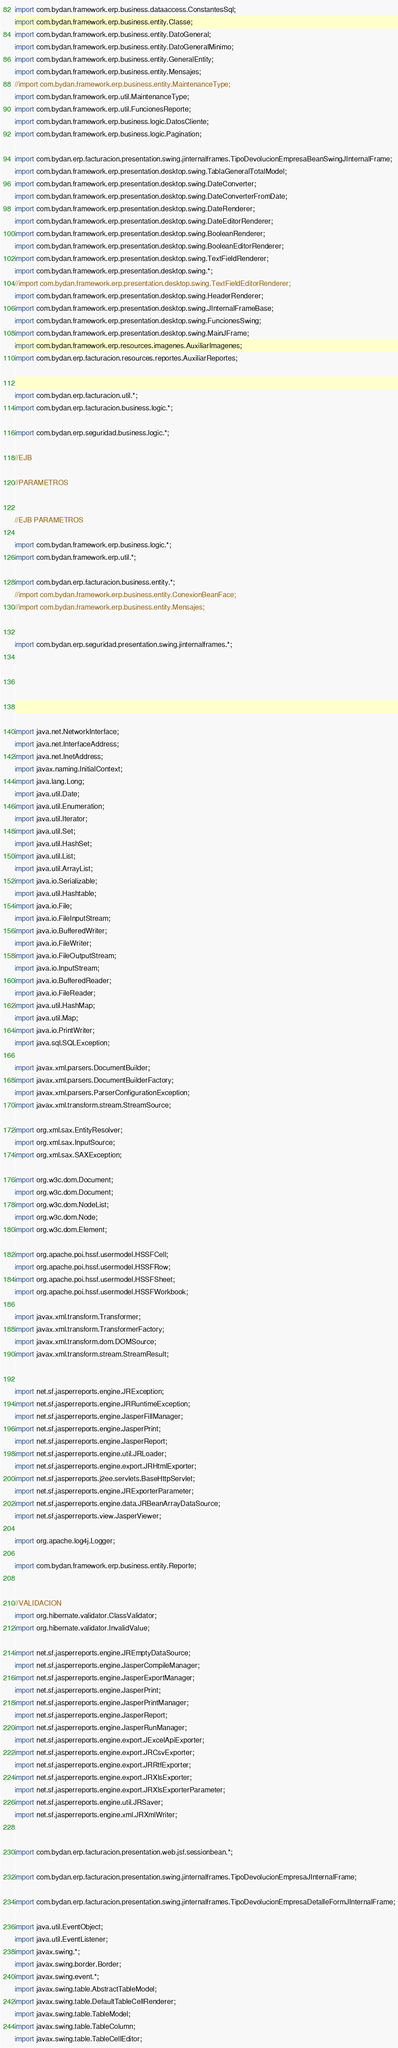Convert code to text. <code><loc_0><loc_0><loc_500><loc_500><_Java_>import com.bydan.framework.erp.business.dataaccess.ConstantesSql;
import com.bydan.framework.erp.business.entity.Classe;
import com.bydan.framework.erp.business.entity.DatoGeneral;
import com.bydan.framework.erp.business.entity.DatoGeneralMinimo;
import com.bydan.framework.erp.business.entity.GeneralEntity;
import com.bydan.framework.erp.business.entity.Mensajes;
//import com.bydan.framework.erp.business.entity.MaintenanceType;
import com.bydan.framework.erp.util.MaintenanceType;
import com.bydan.framework.erp.util.FuncionesReporte;
import com.bydan.framework.erp.business.logic.DatosCliente;
import com.bydan.framework.erp.business.logic.Pagination;

import com.bydan.erp.facturacion.presentation.swing.jinternalframes.TipoDevolucionEmpresaBeanSwingJInternalFrame;
import com.bydan.framework.erp.presentation.desktop.swing.TablaGeneralTotalModel;
import com.bydan.framework.erp.presentation.desktop.swing.DateConverter;
import com.bydan.framework.erp.presentation.desktop.swing.DateConverterFromDate;
import com.bydan.framework.erp.presentation.desktop.swing.DateRenderer;
import com.bydan.framework.erp.presentation.desktop.swing.DateEditorRenderer;
import com.bydan.framework.erp.presentation.desktop.swing.BooleanRenderer;
import com.bydan.framework.erp.presentation.desktop.swing.BooleanEditorRenderer;
import com.bydan.framework.erp.presentation.desktop.swing.TextFieldRenderer;
import com.bydan.framework.erp.presentation.desktop.swing.*;
//import com.bydan.framework.erp.presentation.desktop.swing.TextFieldEditorRenderer;
import com.bydan.framework.erp.presentation.desktop.swing.HeaderRenderer;
import com.bydan.framework.erp.presentation.desktop.swing.JInternalFrameBase;
import com.bydan.framework.erp.presentation.desktop.swing.FuncionesSwing;
import com.bydan.framework.erp.presentation.desktop.swing.MainJFrame;
import com.bydan.framework.erp.resources.imagenes.AuxiliarImagenes;
import com.bydan.erp.facturacion.resources.reportes.AuxiliarReportes;


import com.bydan.erp.facturacion.util.*;
import com.bydan.erp.facturacion.business.logic.*;

import com.bydan.erp.seguridad.business.logic.*;

//EJB

//PARAMETROS


//EJB PARAMETROS

import com.bydan.framework.erp.business.logic.*;
import com.bydan.framework.erp.util.*;

import com.bydan.erp.facturacion.business.entity.*;
//import com.bydan.framework.erp.business.entity.ConexionBeanFace;
//import com.bydan.framework.erp.business.entity.Mensajes;


import com.bydan.erp.seguridad.presentation.swing.jinternalframes.*;






import java.net.NetworkInterface;
import java.net.InterfaceAddress;
import java.net.InetAddress;
import javax.naming.InitialContext;
import java.lang.Long;
import java.util.Date;
import java.util.Enumeration;
import java.util.Iterator;
import java.util.Set;
import java.util.HashSet;
import java.util.List;
import java.util.ArrayList;
import java.io.Serializable;
import java.util.Hashtable;
import java.io.File;
import java.io.FileInputStream;
import java.io.BufferedWriter;
import java.io.FileWriter;
import java.io.FileOutputStream;
import java.io.InputStream;
import java.io.BufferedReader;
import java.io.FileReader;
import java.util.HashMap;
import java.util.Map;
import java.io.PrintWriter;
import java.sql.SQLException;

import javax.xml.parsers.DocumentBuilder;
import javax.xml.parsers.DocumentBuilderFactory;
import javax.xml.parsers.ParserConfigurationException;
import javax.xml.transform.stream.StreamSource;

import org.xml.sax.EntityResolver;
import org.xml.sax.InputSource;
import org.xml.sax.SAXException;

import org.w3c.dom.Document;
import org.w3c.dom.Document;
import org.w3c.dom.NodeList;
import org.w3c.dom.Node;
import org.w3c.dom.Element;

import org.apache.poi.hssf.usermodel.HSSFCell;
import org.apache.poi.hssf.usermodel.HSSFRow;
import org.apache.poi.hssf.usermodel.HSSFSheet;
import org.apache.poi.hssf.usermodel.HSSFWorkbook;

import javax.xml.transform.Transformer;
import javax.xml.transform.TransformerFactory;
import javax.xml.transform.dom.DOMSource;
import javax.xml.transform.stream.StreamResult;


import net.sf.jasperreports.engine.JRException;
import net.sf.jasperreports.engine.JRRuntimeException;
import net.sf.jasperreports.engine.JasperFillManager;
import net.sf.jasperreports.engine.JasperPrint;
import net.sf.jasperreports.engine.JasperReport;
import net.sf.jasperreports.engine.util.JRLoader;
import net.sf.jasperreports.engine.export.JRHtmlExporter;
import net.sf.jasperreports.j2ee.servlets.BaseHttpServlet;
import net.sf.jasperreports.engine.JRExporterParameter;
import net.sf.jasperreports.engine.data.JRBeanArrayDataSource;
import net.sf.jasperreports.view.JasperViewer;

import org.apache.log4j.Logger;

import com.bydan.framework.erp.business.entity.Reporte;


//VALIDACION
import org.hibernate.validator.ClassValidator;
import org.hibernate.validator.InvalidValue;

import net.sf.jasperreports.engine.JREmptyDataSource;
import net.sf.jasperreports.engine.JasperCompileManager;
import net.sf.jasperreports.engine.JasperExportManager;
import net.sf.jasperreports.engine.JasperPrint;
import net.sf.jasperreports.engine.JasperPrintManager;
import net.sf.jasperreports.engine.JasperReport;
import net.sf.jasperreports.engine.JasperRunManager;
import net.sf.jasperreports.engine.export.JExcelApiExporter;
import net.sf.jasperreports.engine.export.JRCsvExporter;
import net.sf.jasperreports.engine.export.JRRtfExporter;
import net.sf.jasperreports.engine.export.JRXlsExporter;
import net.sf.jasperreports.engine.export.JRXlsExporterParameter;
import net.sf.jasperreports.engine.util.JRSaver;
import net.sf.jasperreports.engine.xml.JRXmlWriter;


import com.bydan.erp.facturacion.presentation.web.jsf.sessionbean.*;

import com.bydan.erp.facturacion.presentation.swing.jinternalframes.TipoDevolucionEmpresaJInternalFrame;

import com.bydan.erp.facturacion.presentation.swing.jinternalframes.TipoDevolucionEmpresaDetalleFormJInternalFrame;

import java.util.EventObject;
import java.util.EventListener;
import javax.swing.*;
import javax.swing.border.Border;
import javax.swing.event.*;
import javax.swing.table.AbstractTableModel;
import javax.swing.table.DefaultTableCellRenderer;
import javax.swing.table.TableModel;
import javax.swing.table.TableColumn;
import javax.swing.table.TableCellEditor;</code> 